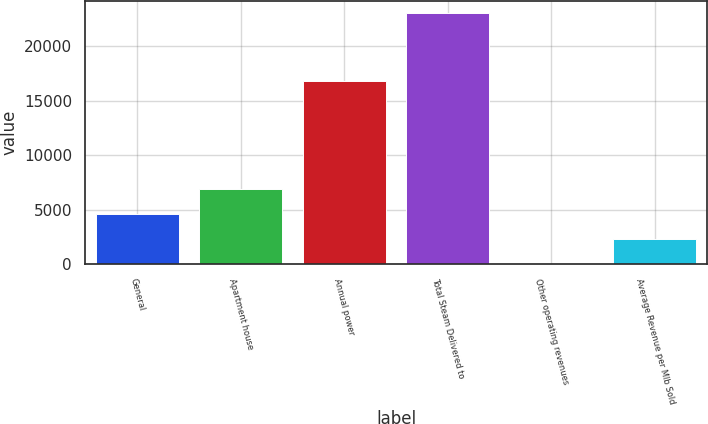Convert chart. <chart><loc_0><loc_0><loc_500><loc_500><bar_chart><fcel>General<fcel>Apartment house<fcel>Annual power<fcel>Total Steam Delivered to<fcel>Other operating revenues<fcel>Average Revenue per Mlb Sold<nl><fcel>4618.8<fcel>6920.2<fcel>16767<fcel>23030<fcel>16<fcel>2317.4<nl></chart> 